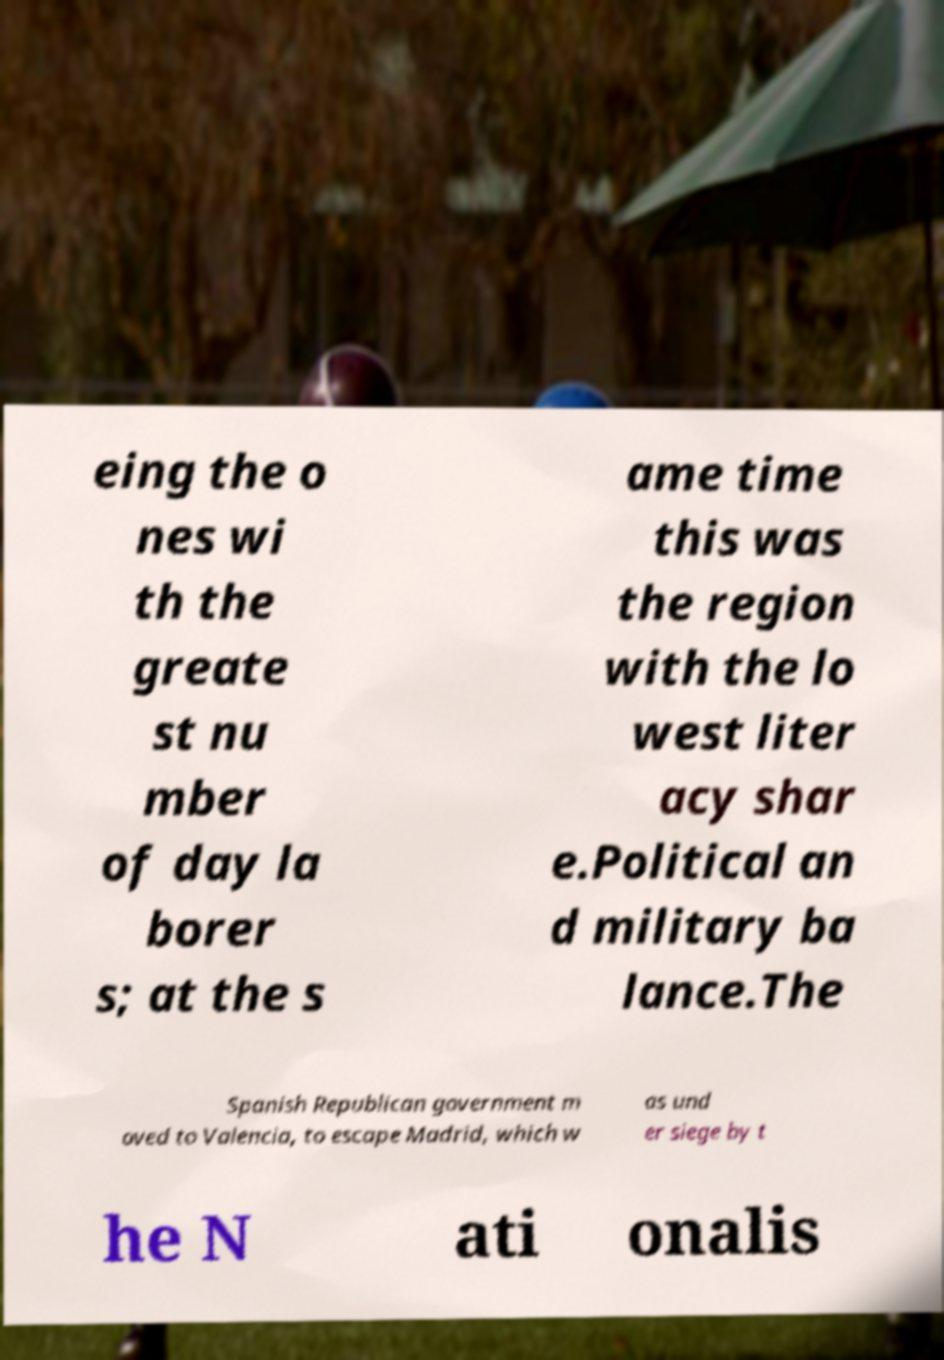For documentation purposes, I need the text within this image transcribed. Could you provide that? eing the o nes wi th the greate st nu mber of day la borer s; at the s ame time this was the region with the lo west liter acy shar e.Political an d military ba lance.The Spanish Republican government m oved to Valencia, to escape Madrid, which w as und er siege by t he N ati onalis 